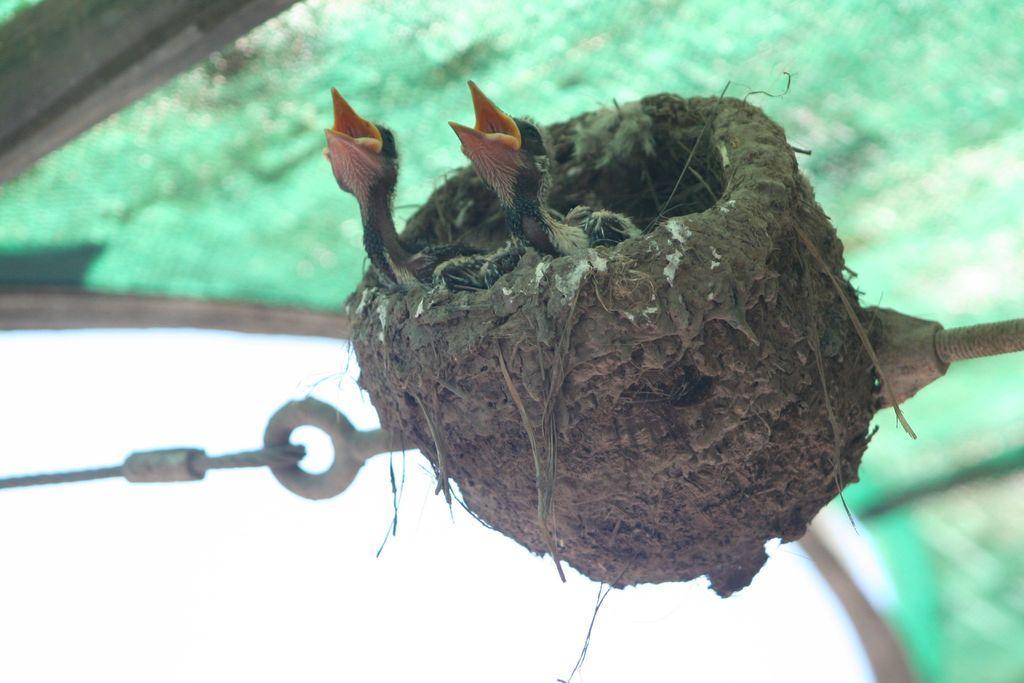How would you summarize this image in a sentence or two? In this image we can see two birds in a nest and we can see metal objects. In the background of the image it is blurry. 